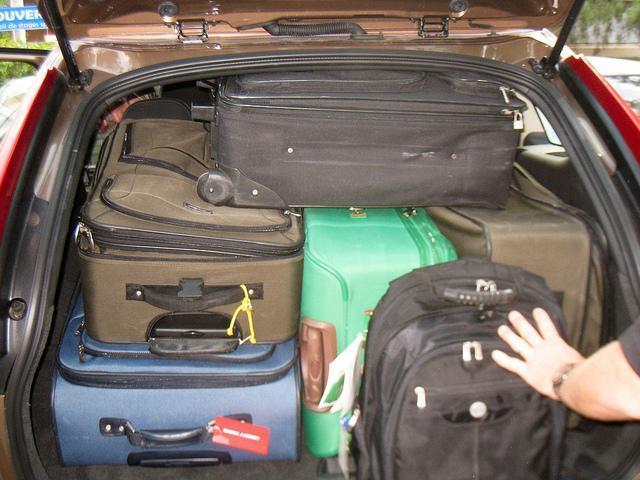How many people are in the picture?
Give a very brief answer. 1. How many suitcases are visible?
Give a very brief answer. 5. 